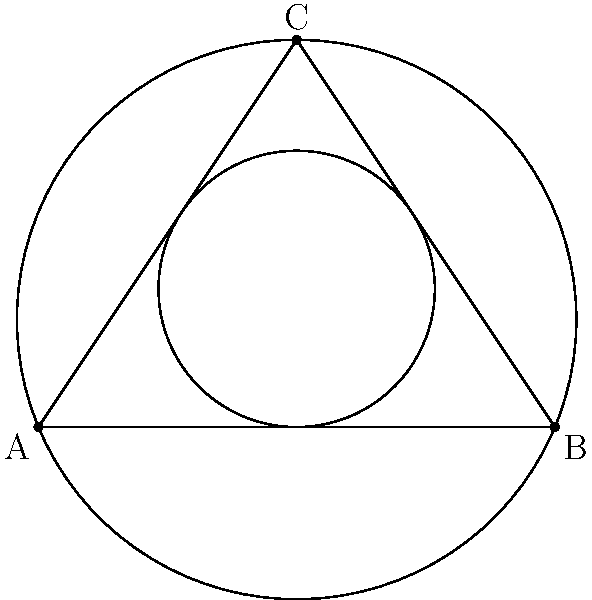In the diagram, a triangle ABC is shown with its inscribed circle (radius $r$) and circumscribed circle (radius $R$). If the area of the triangle is 6 square units and its semi-perimeter is 6 units, determine the ratio of $R$ to $r$. This scenario is analogous to analyzing the relationship between a specific brain region and its surrounding structures. How does this ratio reflect the relative sizes of these circular regions? Let's approach this step-by-step, similar to how we would analyze brain structures:

1) First, recall the formulas for the area of a triangle:
   $$A = rs$$ (where $s$ is the semi-perimeter)
   $$A = \frac{abc}{4R}$$ (where $a$, $b$, and $c$ are the side lengths)

2) We're given that $A = 6$ and $s = 6$. Let's use these in the first formula:
   $$6 = 6r$$
   $$r = 1$$

3) Now, let's use the second formula:
   $$6 = \frac{abc}{4R}$$

4) We can express $abc$ in terms of the semi-perimeter:
   $abc = 4Rs = 4R(6) = 24R$

5) Substituting this back into the equation from step 3:
   $$6 = \frac{24R}{4R} = 6$$

6) Now we have both $R$ and $r$. The ratio $R:r$ is simply:
   $$\frac{R}{r} = \frac{6}{1} = 6$$

This ratio of 6:1 between the circumradius and inradius is reminiscent of how we might compare the size of a specific brain region to the larger structure enclosing it, providing insight into the relative scales of neuroanatomical features.
Answer: $R:r = 6:1$ 